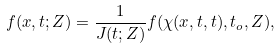<formula> <loc_0><loc_0><loc_500><loc_500>f ( x , t ; Z ) = \frac { 1 } { J ( t ; Z ) } f ( \chi ( x , t , t ) , t _ { o } , Z ) ,</formula> 